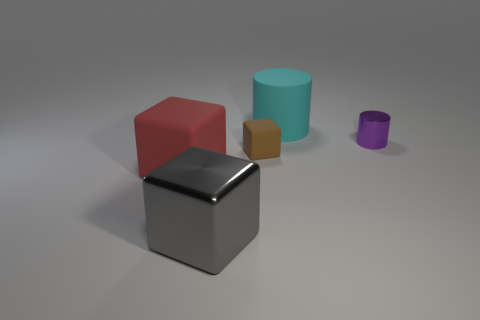Are there more tiny rubber cubes right of the brown rubber block than big metallic objects?
Offer a very short reply. No. What is the shape of the gray metallic object?
Offer a terse response. Cube. There is a object that is in front of the big red block; does it have the same color as the matte cube that is in front of the brown object?
Offer a terse response. No. Do the big red rubber object and the tiny brown matte thing have the same shape?
Offer a very short reply. Yes. Is there anything else that is the same shape as the tiny purple metal thing?
Make the answer very short. Yes. Are the big block that is left of the large gray cube and the large cyan cylinder made of the same material?
Offer a terse response. Yes. There is a thing that is in front of the big rubber cylinder and on the right side of the tiny block; what is its shape?
Offer a very short reply. Cylinder. There is a big matte thing that is to the left of the big cyan cylinder; are there any gray blocks that are on the left side of it?
Offer a very short reply. No. What number of other things are there of the same material as the big cylinder
Your answer should be very brief. 2. There is a metal thing behind the large gray block; does it have the same shape as the red thing that is left of the tiny brown rubber block?
Your answer should be very brief. No. 